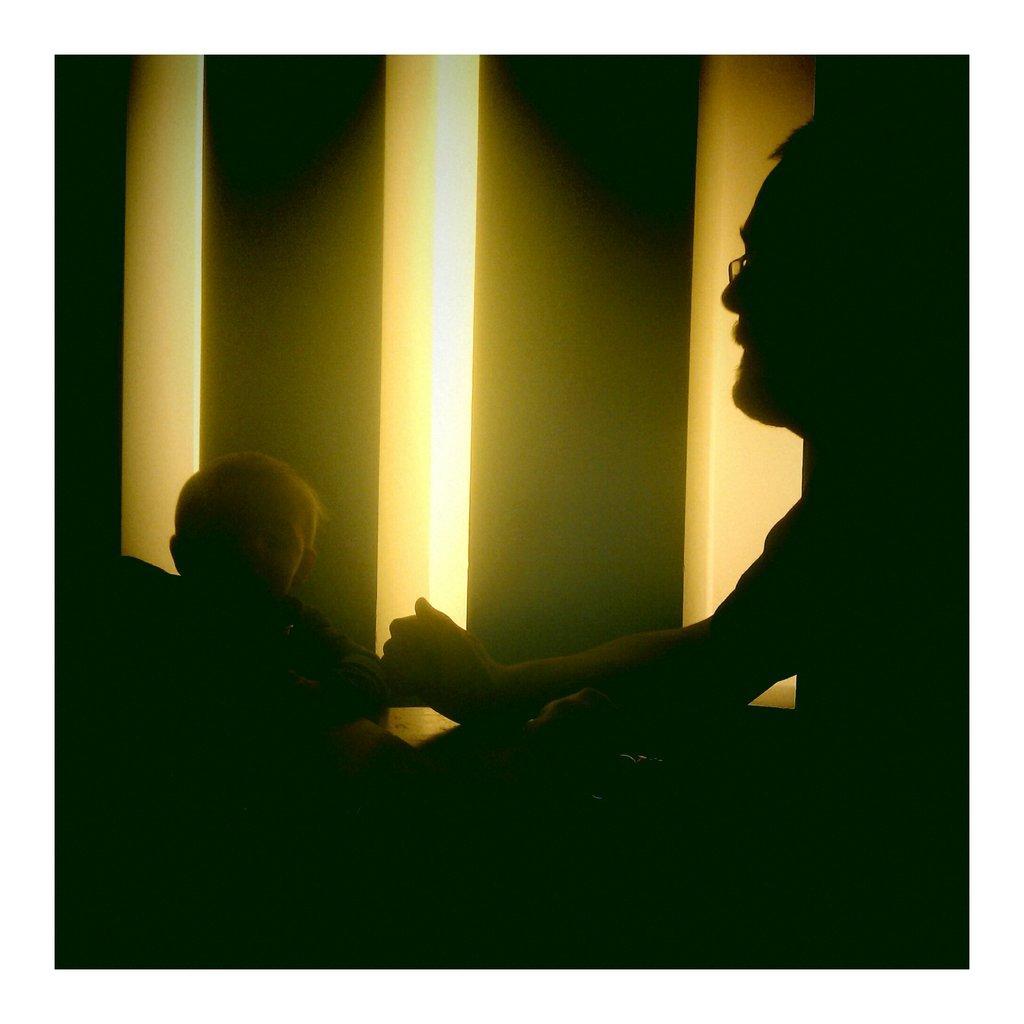Can you describe this image briefly? In this image we can see a man and a boy. Background of the image it seems like pillars are there. 